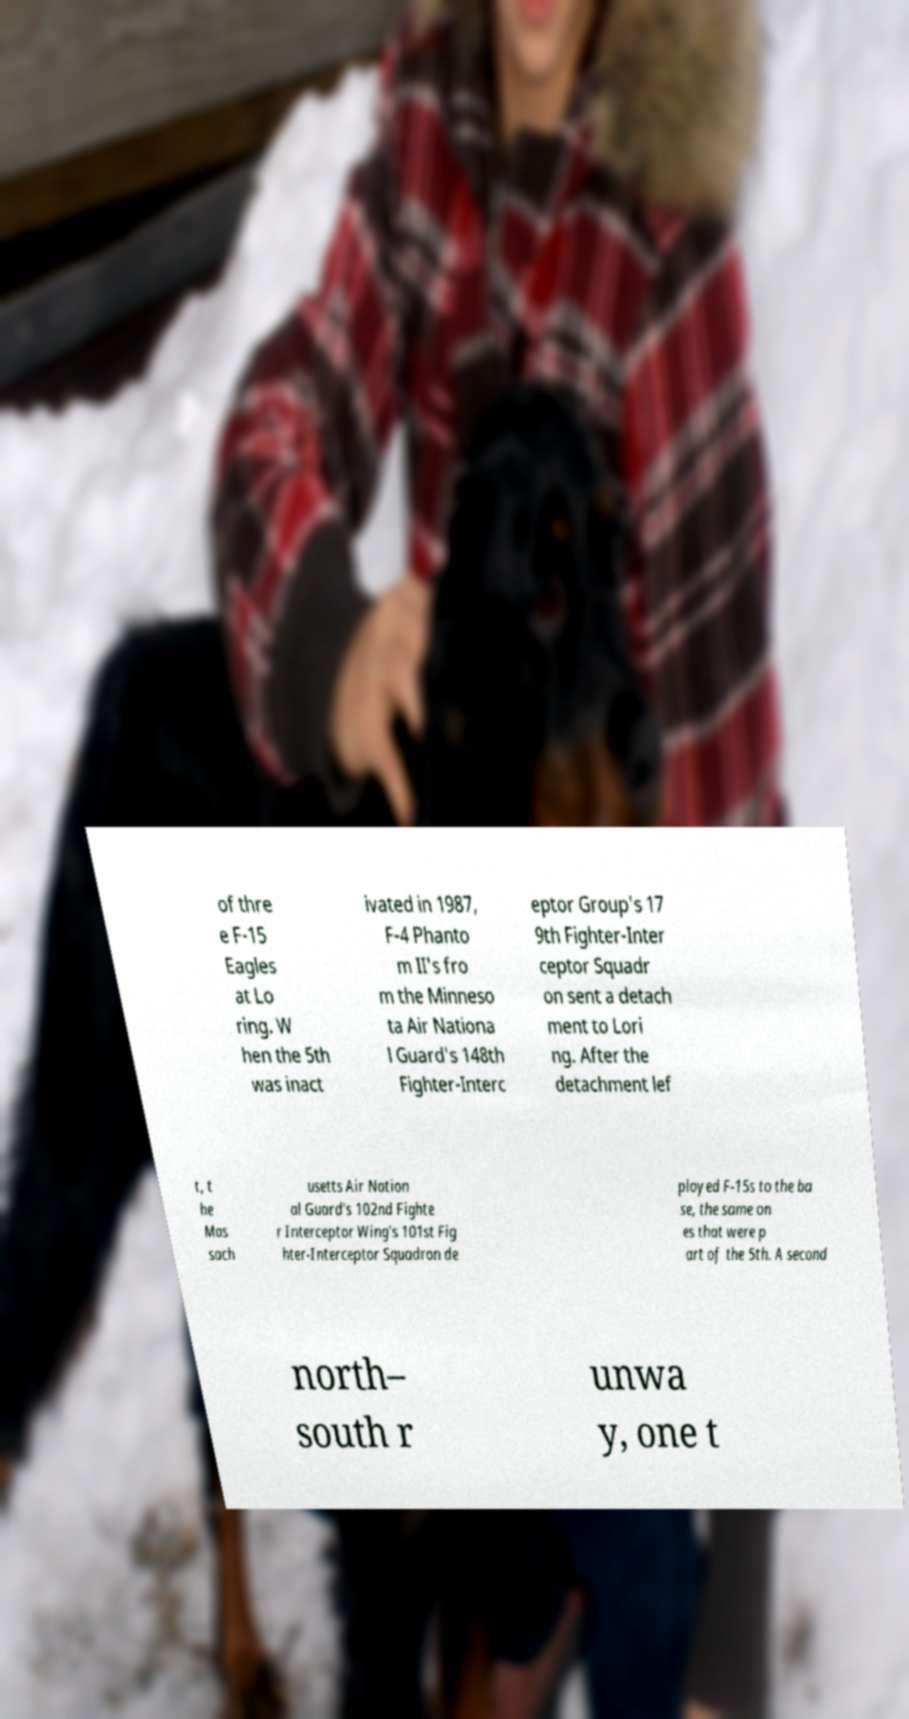Please read and relay the text visible in this image. What does it say? of thre e F-15 Eagles at Lo ring. W hen the 5th was inact ivated in 1987, F-4 Phanto m II's fro m the Minneso ta Air Nationa l Guard's 148th Fighter-Interc eptor Group's 17 9th Fighter-Inter ceptor Squadr on sent a detach ment to Lori ng. After the detachment lef t, t he Mas sach usetts Air Nation al Guard's 102nd Fighte r Interceptor Wing's 101st Fig hter-Interceptor Squadron de ployed F-15s to the ba se, the same on es that were p art of the 5th. A second north– south r unwa y, one t 